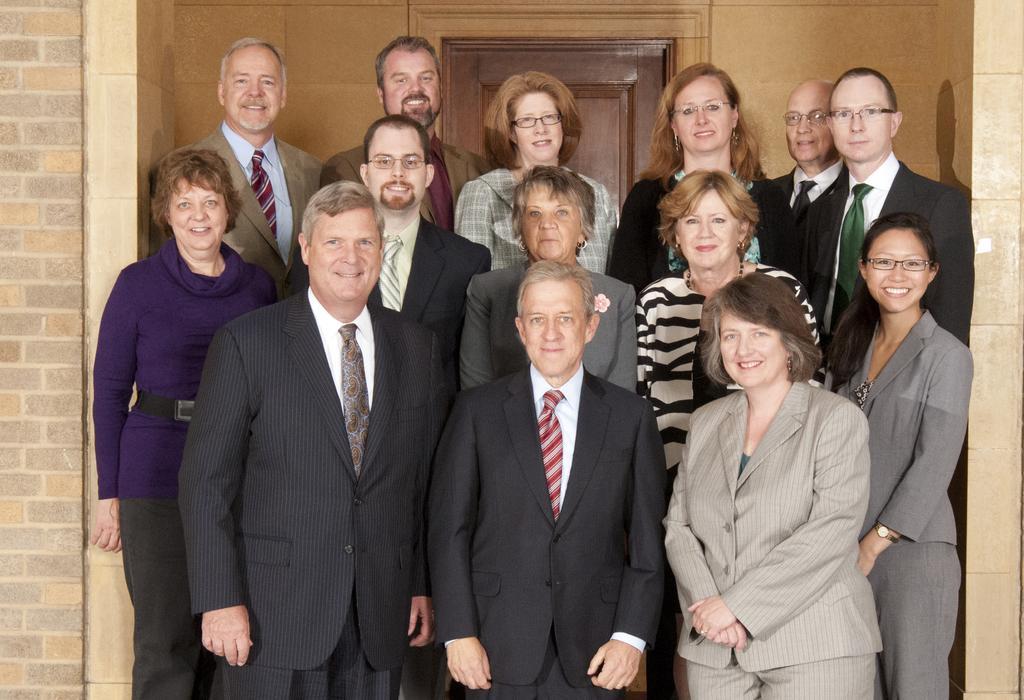In one or two sentences, can you explain what this image depicts? Here we can see few persons are standing and they are smiling. In the background we can see a wall and a door. 